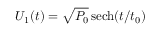<formula> <loc_0><loc_0><loc_500><loc_500>U _ { 1 } ( t ) = \sqrt { P _ { 0 } } \, { s e c h } ( t / t _ { 0 } )</formula> 